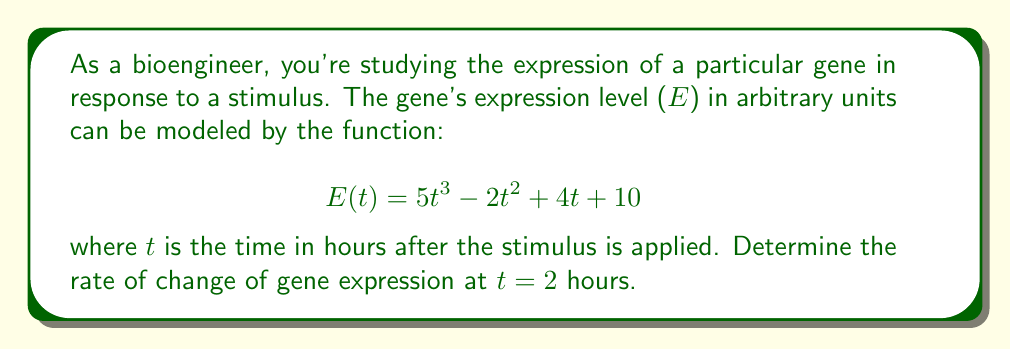Provide a solution to this math problem. To solve this problem, we need to find the derivative of the gene expression function and then evaluate it at t = 2 hours. Here's the step-by-step process:

1. The given function for gene expression is:
   $$E(t) = 5t^3 - 2t^2 + 4t + 10$$

2. To find the rate of change, we need to calculate the derivative $\frac{dE}{dt}$:
   $$\frac{dE}{dt} = \frac{d}{dt}(5t^3 - 2t^2 + 4t + 10)$$

3. Using the power rule and the constant rule of differentiation:
   $$\frac{dE}{dt} = 15t^2 - 4t + 4$$

4. This derivative function represents the instantaneous rate of change of gene expression at any time t.

5. To find the rate of change at t = 2 hours, we substitute t = 2 into the derivative function:
   $$\frac{dE}{dt}\Big|_{t=2} = 15(2)^2 - 4(2) + 4$$
   $$= 15(4) - 8 + 4$$
   $$= 60 - 8 + 4$$
   $$= 56$$

Therefore, the rate of change of gene expression at t = 2 hours is 56 arbitrary units per hour.
Answer: The rate of change of gene expression at t = 2 hours is 56 arbitrary units per hour. 